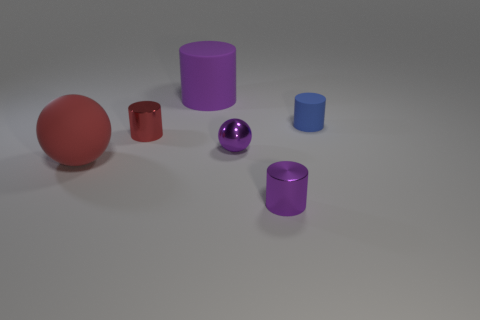Is there a small cylinder that has the same color as the big ball?
Provide a short and direct response. Yes. Does the large matte cylinder have the same color as the shiny sphere?
Your answer should be compact. Yes. What shape is the large thing that is the same color as the small metal ball?
Provide a short and direct response. Cylinder. How many objects are either cylinders that are in front of the tiny ball or tiny things that are behind the big red sphere?
Your answer should be very brief. 4. Is the number of large red things less than the number of red metal balls?
Keep it short and to the point. No. What number of things are metal objects or large purple rubber objects?
Ensure brevity in your answer.  4. Do the red metallic object and the tiny blue thing have the same shape?
Offer a very short reply. Yes. Is the size of the shiny cylinder that is in front of the metal ball the same as the purple cylinder that is behind the large matte sphere?
Your response must be concise. No. There is a tiny object that is behind the purple ball and left of the blue cylinder; what material is it made of?
Make the answer very short. Metal. Is there anything else that has the same color as the tiny matte cylinder?
Offer a very short reply. No. 